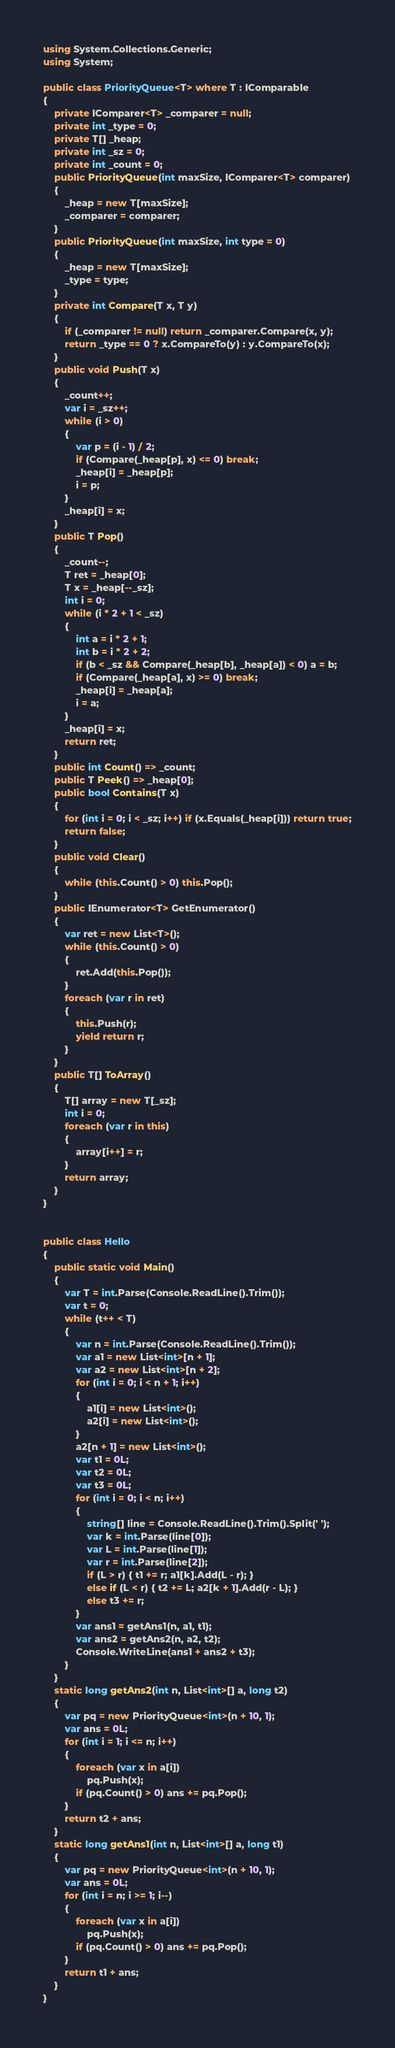<code> <loc_0><loc_0><loc_500><loc_500><_C#_>using System.Collections.Generic;
using System;

public class PriorityQueue<T> where T : IComparable
{
    private IComparer<T> _comparer = null;
    private int _type = 0;
    private T[] _heap;
    private int _sz = 0;
    private int _count = 0;
    public PriorityQueue(int maxSize, IComparer<T> comparer)
    {
        _heap = new T[maxSize];
        _comparer = comparer;
    }
    public PriorityQueue(int maxSize, int type = 0)
    {
        _heap = new T[maxSize];
        _type = type;
    }
    private int Compare(T x, T y)
    {
        if (_comparer != null) return _comparer.Compare(x, y);
        return _type == 0 ? x.CompareTo(y) : y.CompareTo(x);
    }
    public void Push(T x)
    {
        _count++;
        var i = _sz++;
        while (i > 0)
        {
            var p = (i - 1) / 2;
            if (Compare(_heap[p], x) <= 0) break;
            _heap[i] = _heap[p];
            i = p;
        }
        _heap[i] = x;
    }
    public T Pop()
    {
        _count--;
        T ret = _heap[0];
        T x = _heap[--_sz];
        int i = 0;
        while (i * 2 + 1 < _sz)
        {
            int a = i * 2 + 1;
            int b = i * 2 + 2;
            if (b < _sz && Compare(_heap[b], _heap[a]) < 0) a = b;
            if (Compare(_heap[a], x) >= 0) break;
            _heap[i] = _heap[a];
            i = a;
        }
        _heap[i] = x;
        return ret;
    }
    public int Count() => _count;
    public T Peek() => _heap[0];
    public bool Contains(T x)
    {
        for (int i = 0; i < _sz; i++) if (x.Equals(_heap[i])) return true;
        return false;
    }
    public void Clear()
    {
        while (this.Count() > 0) this.Pop();
    }
    public IEnumerator<T> GetEnumerator()
    {
        var ret = new List<T>();
        while (this.Count() > 0)
        {
            ret.Add(this.Pop());
        }
        foreach (var r in ret)
        {
            this.Push(r);
            yield return r;
        }
    }
    public T[] ToArray()
    {
        T[] array = new T[_sz];
        int i = 0;
        foreach (var r in this)
        {
            array[i++] = r;
        }
        return array;
    }
}


public class Hello
{
    public static void Main()
    {
        var T = int.Parse(Console.ReadLine().Trim());
        var t = 0;
        while (t++ < T)
        {
            var n = int.Parse(Console.ReadLine().Trim());
            var a1 = new List<int>[n + 1];
            var a2 = new List<int>[n + 2];
            for (int i = 0; i < n + 1; i++)
            {
                a1[i] = new List<int>();
                a2[i] = new List<int>();
            }
            a2[n + 1] = new List<int>();
            var t1 = 0L;
            var t2 = 0L;
            var t3 = 0L;
            for (int i = 0; i < n; i++)
            {
                string[] line = Console.ReadLine().Trim().Split(' ');
                var k = int.Parse(line[0]);
                var L = int.Parse(line[1]);
                var r = int.Parse(line[2]);
                if (L > r) { t1 += r; a1[k].Add(L - r); }
                else if (L < r) { t2 += L; a2[k + 1].Add(r - L); }
                else t3 += r;
            }
            var ans1 = getAns1(n, a1, t1);
            var ans2 = getAns2(n, a2, t2);
            Console.WriteLine(ans1 + ans2 + t3);
        }
    }
    static long getAns2(int n, List<int>[] a, long t2)
    {
        var pq = new PriorityQueue<int>(n + 10, 1);
        var ans = 0L;
        for (int i = 1; i <= n; i++)
        {
            foreach (var x in a[i])
                pq.Push(x);
            if (pq.Count() > 0) ans += pq.Pop();
        }
        return t2 + ans;
    }
    static long getAns1(int n, List<int>[] a, long t1)
    {
        var pq = new PriorityQueue<int>(n + 10, 1);
        var ans = 0L;
        for (int i = n; i >= 1; i--)
        {
            foreach (var x in a[i])
                pq.Push(x);
            if (pq.Count() > 0) ans += pq.Pop();
        }
        return t1 + ans;
    }
}
</code> 